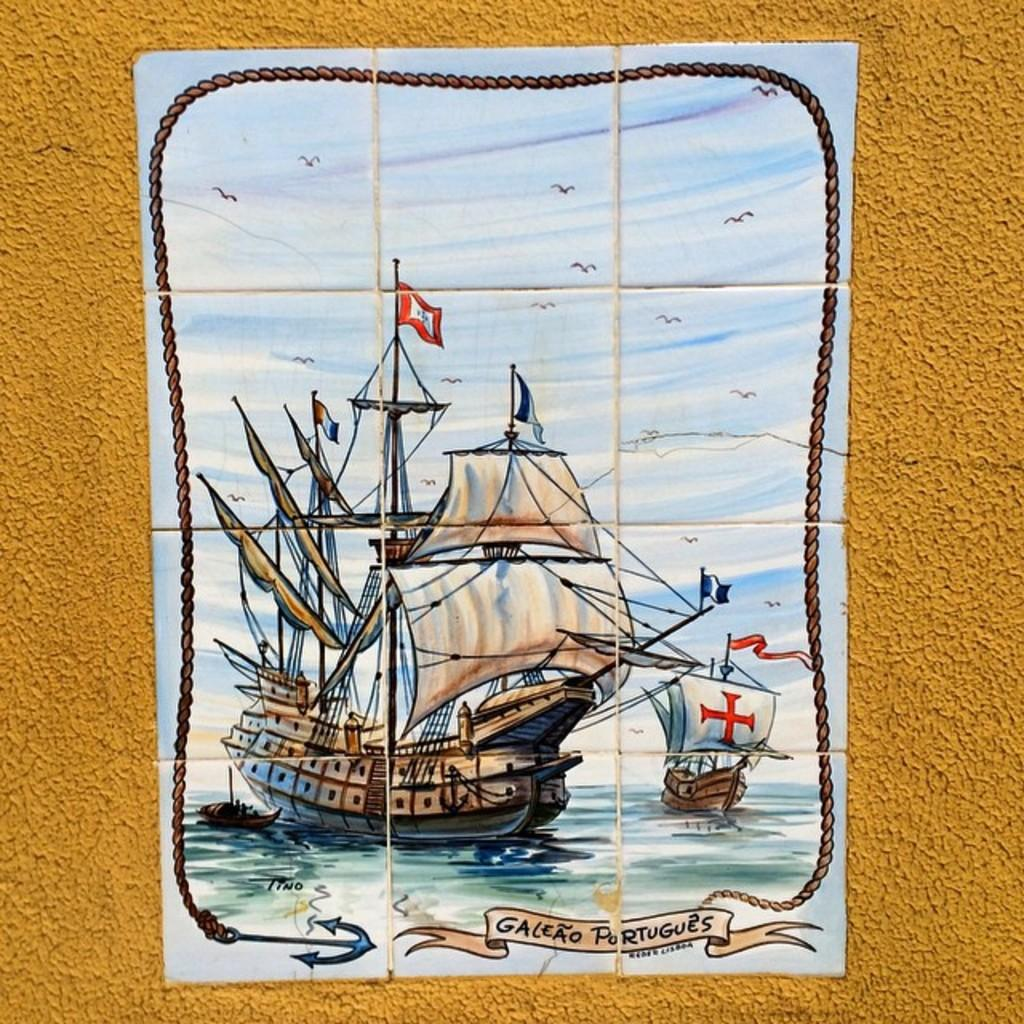<image>
Summarize the visual content of the image. A piece of artwork on a brown background containing the word Portugues 